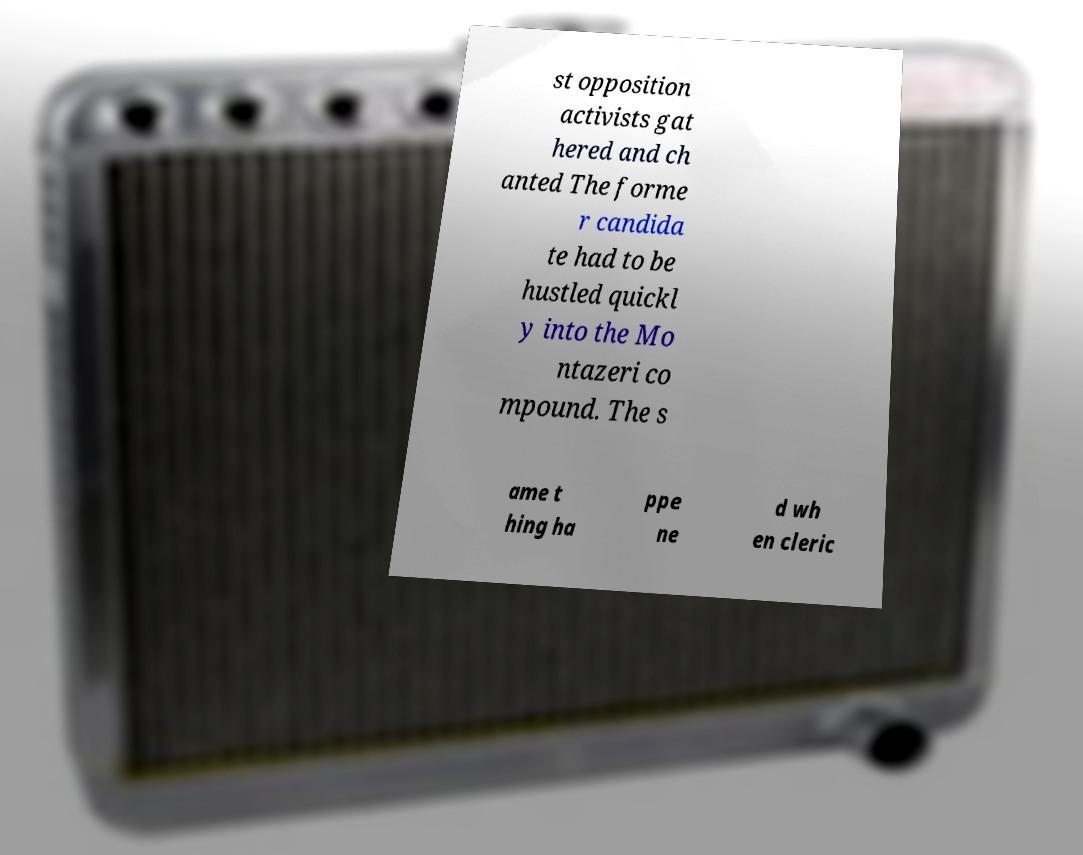For documentation purposes, I need the text within this image transcribed. Could you provide that? st opposition activists gat hered and ch anted The forme r candida te had to be hustled quickl y into the Mo ntazeri co mpound. The s ame t hing ha ppe ne d wh en cleric 